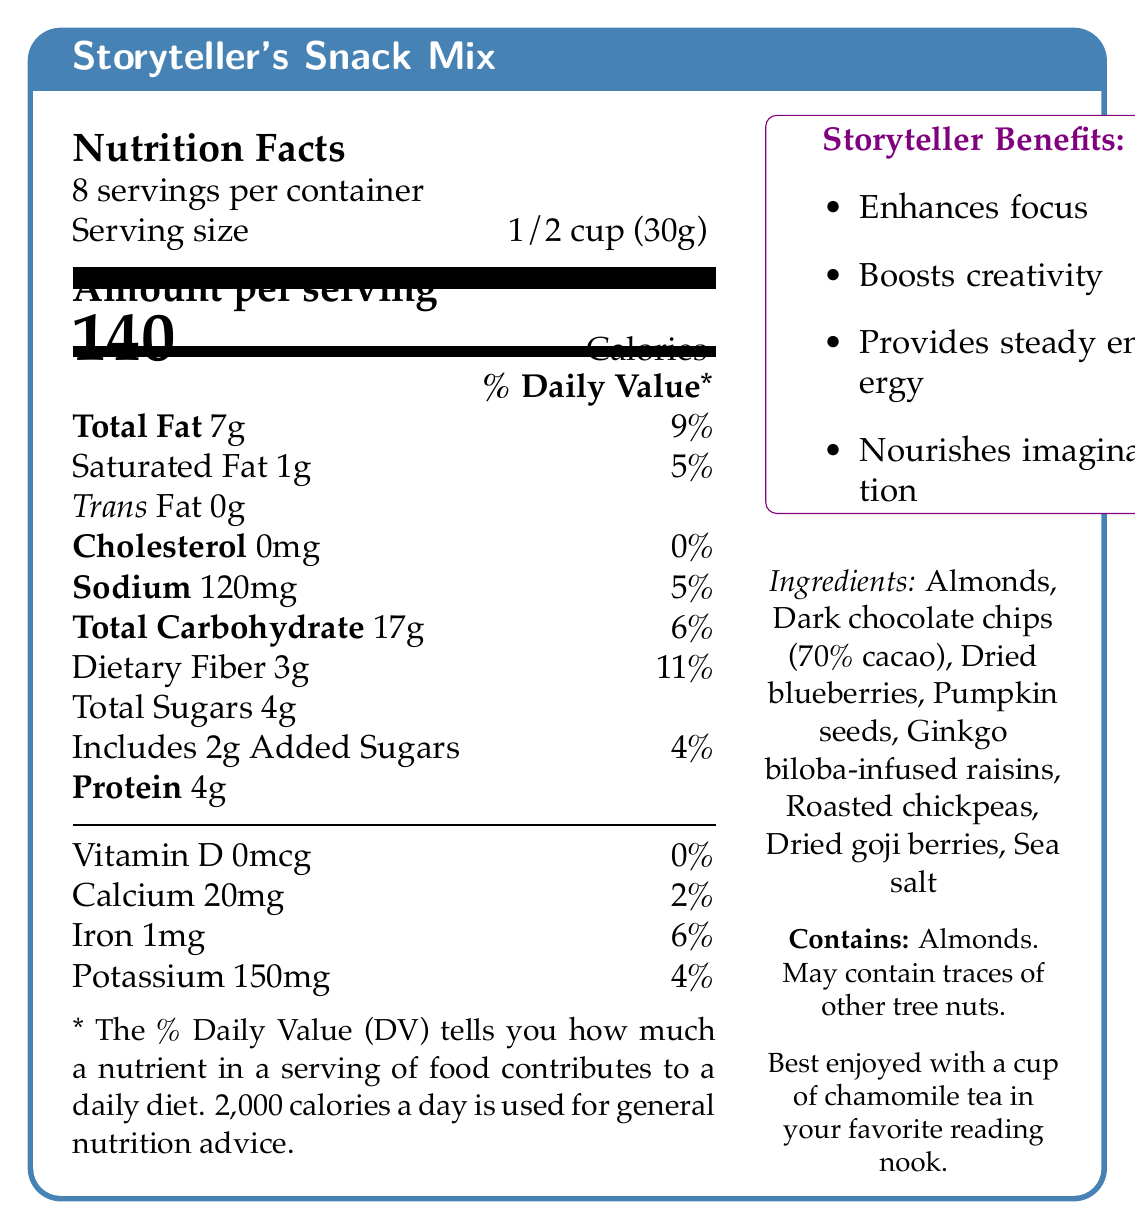what is the serving size for Storyteller's Snack Mix? The serving size is explicitly mentioned in the "Serving size" section of the nutrition facts.
Answer: 1/2 cup (30g) how many servings are there per container? The document states this information right below the product name in the nutrition facts box.
Answer: 8 how many calories are in one serving? The amount of calories per serving is highlighted in large letters in the "Amount per serving" section.
Answer: 140 what percentage of the daily value does the total fat in one serving represent? This percentage is found next to the "Total Fat" description.
Answer: 9% how much dietary fiber does one serving contain? The dietary fiber content is listed under the "Total Carbohydrate" section.
Answer: 3g what are the total sugars in one serving? A. 2g B. 4g C. 6g The document states "Total Sugars 4g" in the nutrition facts panel.
Answer: B which ingredient is NOT listed? A. Almonds B. Dark chocolate chips C. Cashews D. Pumpkin seeds Cashews are not mentioned in the ingredients list; Almonds, Dark chocolate chips, and Pumpkin seeds are all listed.
Answer: C does the Storyteller's Snack Mix contain any cholesterol? The nutrition facts list "Cholesterol 0mg" with a daily value percentage of 0%.
Answer: No is the packaging environmentally friendly? The document mentions that the packaging is "Eco-friendly, resealable pouch made from recycled materials."
Answer: Yes summarize the key benefits of Storyteller's Snack Mix. The document outlines the specific benefits in the "Storyteller Benefits" section: Enhances focus, boosts creativity, provides steady energy, and nourishes imagination.
Answer: Enhances focus, boosts creativity, provides steady energy, nourishes imagination. how much calcium is in one serving of Storyteller's Snack Mix? The calcium content per serving is listed in the nutrition facts under "Calcium."
Answer: 20mg does the snack contain any trans fat? The document specifies "Trans Fat 0g" under the fat content.
Answer: No which special feature does the snack NOT offer? A. High in protein B. Rich in omega-3 fatty acids C. Contains antioxidants D. Low glycemic index The special features listed include being rich in omega-3 fatty acids, containing antioxidants, and having a low glycemic index, but not "High in protein."
Answer: A how long is the shelf life of this product? The document notes that the shelf life is "6 months when stored in a cool, dry place."
Answer: 6 months is there an allergen warning on this product? The document contains an allergen warning stating "Contains: Almonds. May contain traces of other tree nuts."
Answer: Yes what is the recommended pairing with this snack? The recommended pairings listed are a cup of chamomile tea, your favorite leather-bound journal, and a cozy reading nook by the window.
Answer: A cup of chamomile tea, your favorite leather-bound journal, a cozy reading nook by the window. what is the main idea of this document? The document highlights the nutritional information, ingredients, benefits, and recommended use of Storyteller's Snack Mix, which is designed to boost cognitive performance and is packaged sustainably.
Answer: The nutrition facts and special features of Storyteller's Snack Mix, an eco-friendly product designed to enhance focus and creativity. how many grams of added sugars are there in one serving? The document states "Includes 2g Added Sugars" under the "Total Sugars" section.
Answer: 2g what is the major benefit of Ginkgo biloba in the snack mix? The document highlights Ginkgo biloba for its ability to improve memory and concentration as one of the special features.
Answer: Improved memory and concentration 